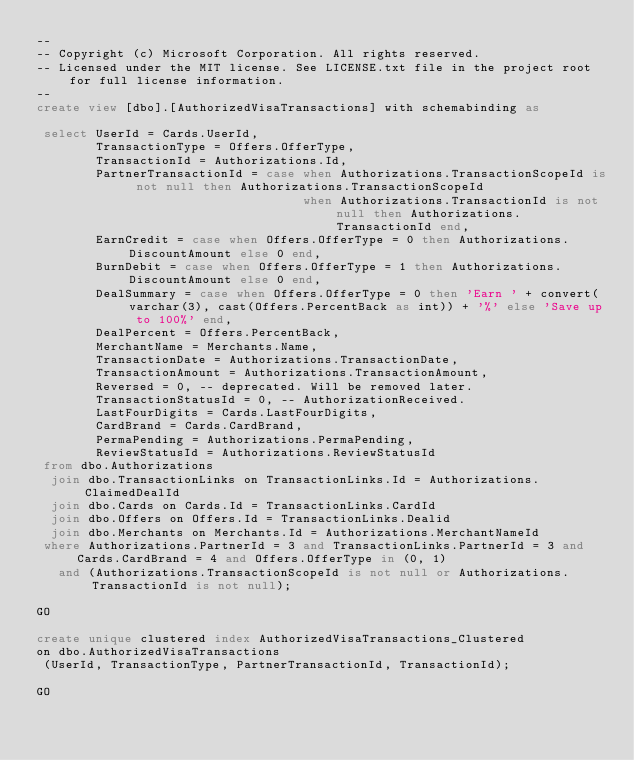Convert code to text. <code><loc_0><loc_0><loc_500><loc_500><_SQL_>--
-- Copyright (c) Microsoft Corporation. All rights reserved. 
-- Licensed under the MIT license. See LICENSE.txt file in the project root for full license information.
--
create view [dbo].[AuthorizedVisaTransactions] with schemabinding as

 select UserId = Cards.UserId,
        TransactionType = Offers.OfferType,
        TransactionId = Authorizations.Id,
        PartnerTransactionId = case when Authorizations.TransactionScopeId is not null then Authorizations.TransactionScopeId
                                    when Authorizations.TransactionId is not null then Authorizations.TransactionId end,
        EarnCredit = case when Offers.OfferType = 0 then Authorizations.DiscountAmount else 0 end,
        BurnDebit = case when Offers.OfferType = 1 then Authorizations.DiscountAmount else 0 end,
        DealSummary = case when Offers.OfferType = 0 then 'Earn ' + convert(varchar(3), cast(Offers.PercentBack as int)) + '%' else 'Save up to 100%' end,
        DealPercent = Offers.PercentBack,
        MerchantName = Merchants.Name,
        TransactionDate = Authorizations.TransactionDate,
        TransactionAmount = Authorizations.TransactionAmount,
        Reversed = 0, -- deprecated. Will be removed later.
        TransactionStatusId = 0, -- AuthorizationReceived.
        LastFourDigits = Cards.LastFourDigits,
        CardBrand = Cards.CardBrand,
        PermaPending = Authorizations.PermaPending,
        ReviewStatusId = Authorizations.ReviewStatusId
 from dbo.Authorizations
  join dbo.TransactionLinks on TransactionLinks.Id = Authorizations.ClaimedDealId
  join dbo.Cards on Cards.Id = TransactionLinks.CardId
  join dbo.Offers on Offers.Id = TransactionLinks.Dealid
  join dbo.Merchants on Merchants.Id = Authorizations.MerchantNameId
 where Authorizations.PartnerId = 3 and TransactionLinks.PartnerId = 3 and Cards.CardBrand = 4 and Offers.OfferType in (0, 1)
   and (Authorizations.TransactionScopeId is not null or Authorizations.TransactionId is not null);

GO

create unique clustered index AuthorizedVisaTransactions_Clustered
on dbo.AuthorizedVisaTransactions
 (UserId, TransactionType, PartnerTransactionId, TransactionId);

GO</code> 